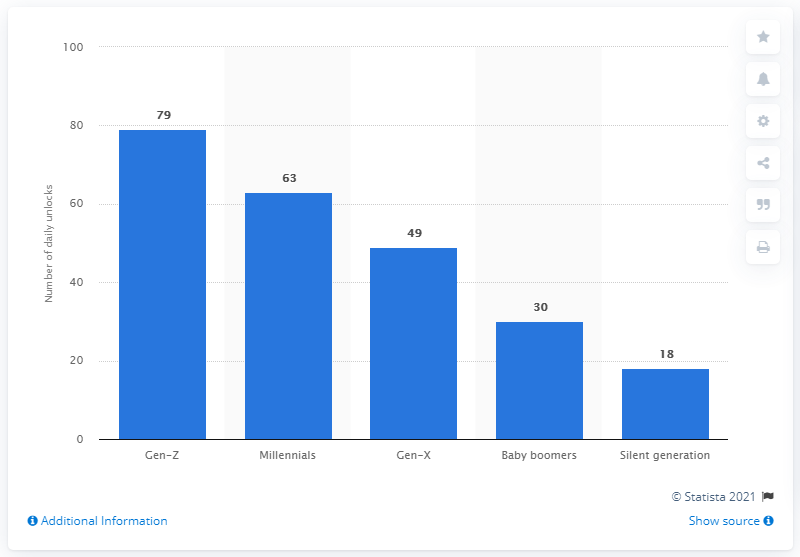Indicate a few pertinent items in this graphic. According to a study, millennials unlock their phones an average of 63 times per day. On average, Gen Z smartphone users unlock their devices 79 times per day. 